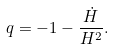<formula> <loc_0><loc_0><loc_500><loc_500>q = - 1 - \frac { \dot { H } } { H ^ { 2 } } .</formula> 